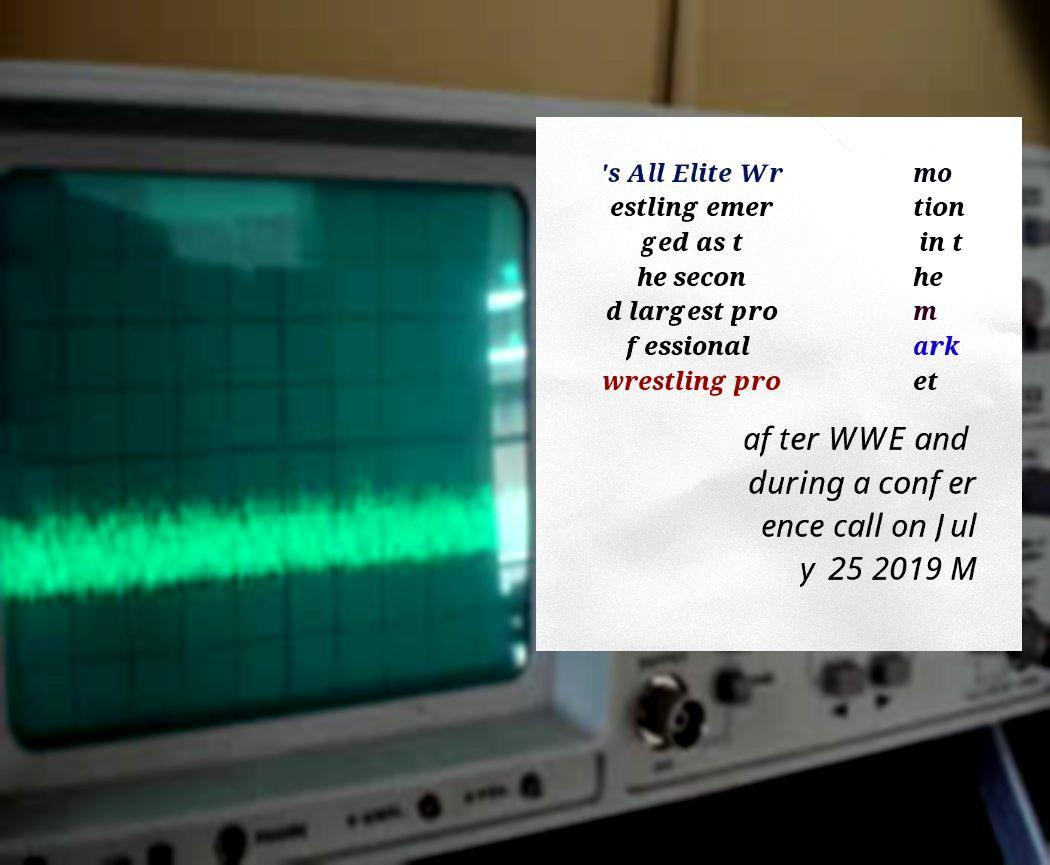Please identify and transcribe the text found in this image. 's All Elite Wr estling emer ged as t he secon d largest pro fessional wrestling pro mo tion in t he m ark et after WWE and during a confer ence call on Jul y 25 2019 M 